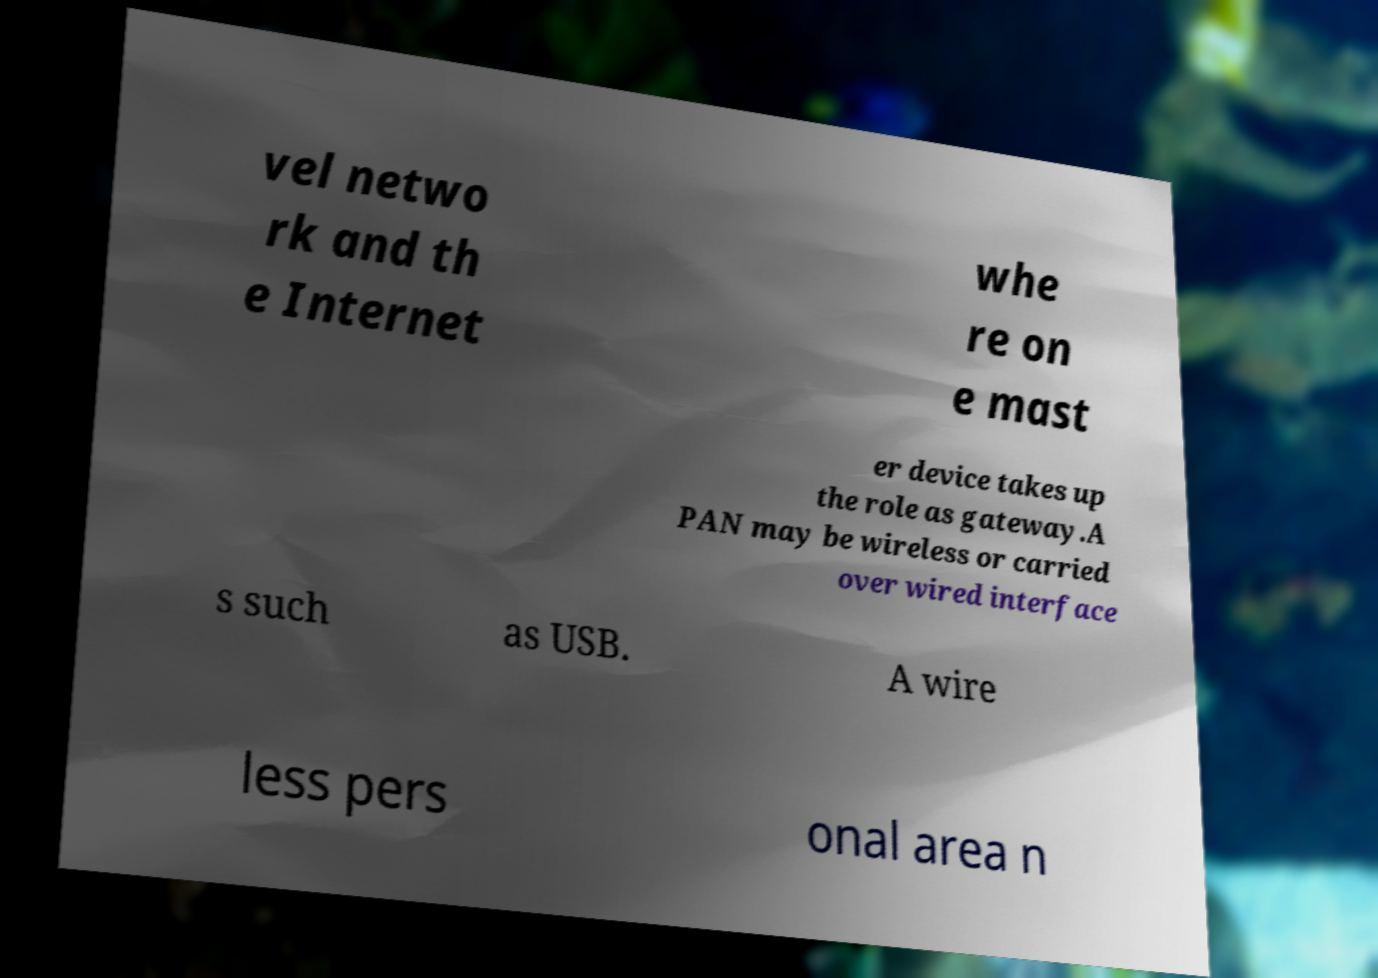Please identify and transcribe the text found in this image. vel netwo rk and th e Internet whe re on e mast er device takes up the role as gateway.A PAN may be wireless or carried over wired interface s such as USB. A wire less pers onal area n 